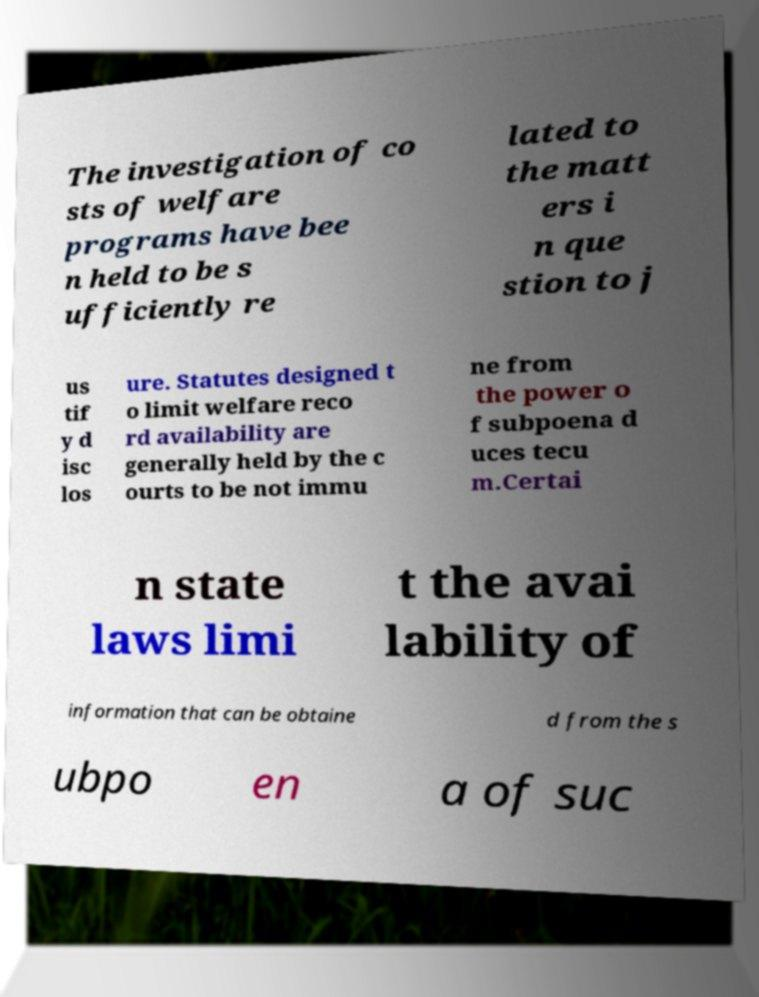There's text embedded in this image that I need extracted. Can you transcribe it verbatim? The investigation of co sts of welfare programs have bee n held to be s ufficiently re lated to the matt ers i n que stion to j us tif y d isc los ure. Statutes designed t o limit welfare reco rd availability are generally held by the c ourts to be not immu ne from the power o f subpoena d uces tecu m.Certai n state laws limi t the avai lability of information that can be obtaine d from the s ubpo en a of suc 